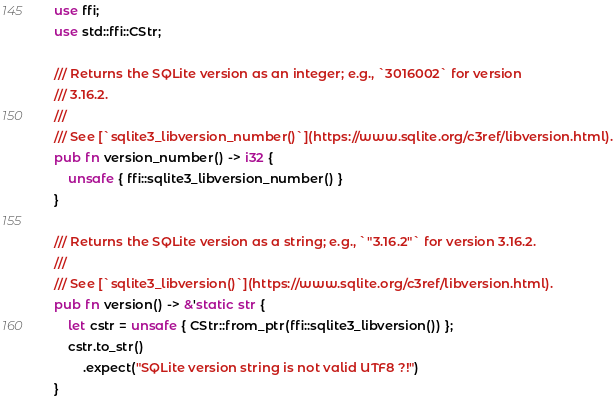Convert code to text. <code><loc_0><loc_0><loc_500><loc_500><_Rust_>use ffi;
use std::ffi::CStr;

/// Returns the SQLite version as an integer; e.g., `3016002` for version
/// 3.16.2.
///
/// See [`sqlite3_libversion_number()`](https://www.sqlite.org/c3ref/libversion.html).
pub fn version_number() -> i32 {
    unsafe { ffi::sqlite3_libversion_number() }
}

/// Returns the SQLite version as a string; e.g., `"3.16.2"` for version 3.16.2.
///
/// See [`sqlite3_libversion()`](https://www.sqlite.org/c3ref/libversion.html).
pub fn version() -> &'static str {
    let cstr = unsafe { CStr::from_ptr(ffi::sqlite3_libversion()) };
    cstr.to_str()
        .expect("SQLite version string is not valid UTF8 ?!")
}
</code> 